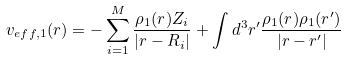Convert formula to latex. <formula><loc_0><loc_0><loc_500><loc_500>v _ { e f f , 1 } ( { r } ) = - \sum _ { i = 1 } ^ { M } \frac { \rho _ { 1 } ( { r } ) Z _ { i } } { | { r } - { R } _ { i } | } + \int d ^ { 3 } { r } ^ { \prime } \frac { \rho _ { 1 } ( { r } ) \rho _ { 1 } ( { r } ^ { \prime } ) } { | { r } - { r } ^ { \prime } | }</formula> 